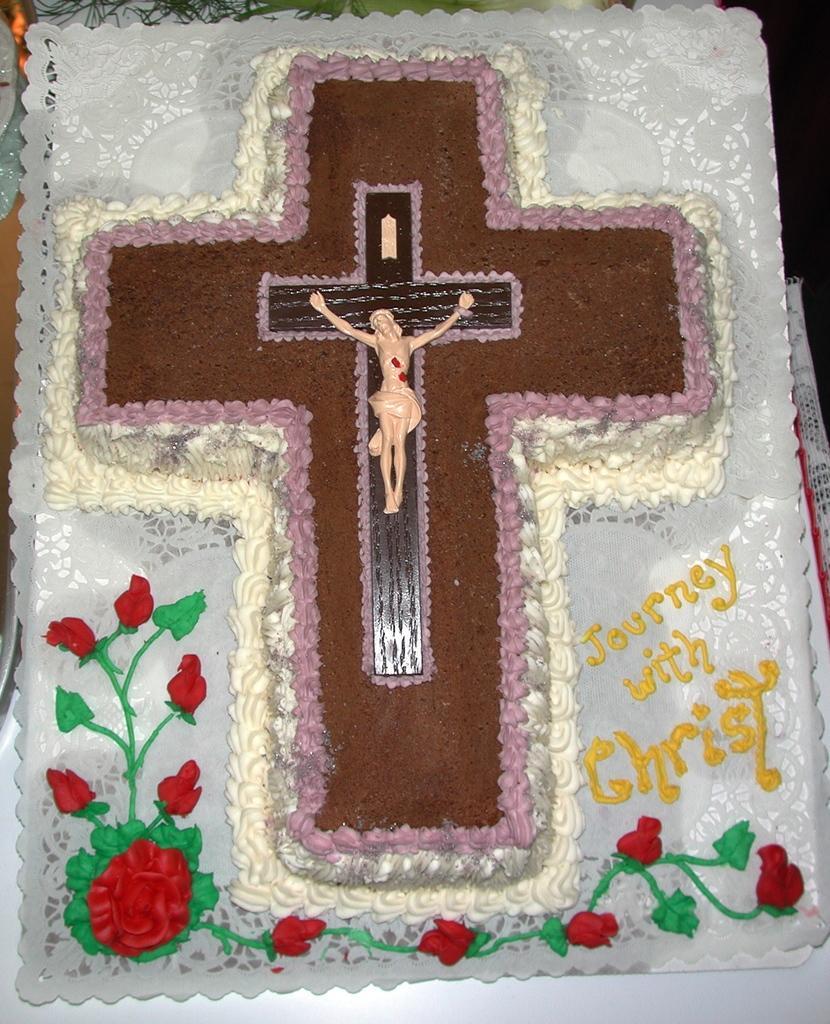How would you summarize this image in a sentence or two? In the image in the center we can see one frame. On the frame,we can see some design and cross. And on the frame,it is written as "Journey With Christ". 